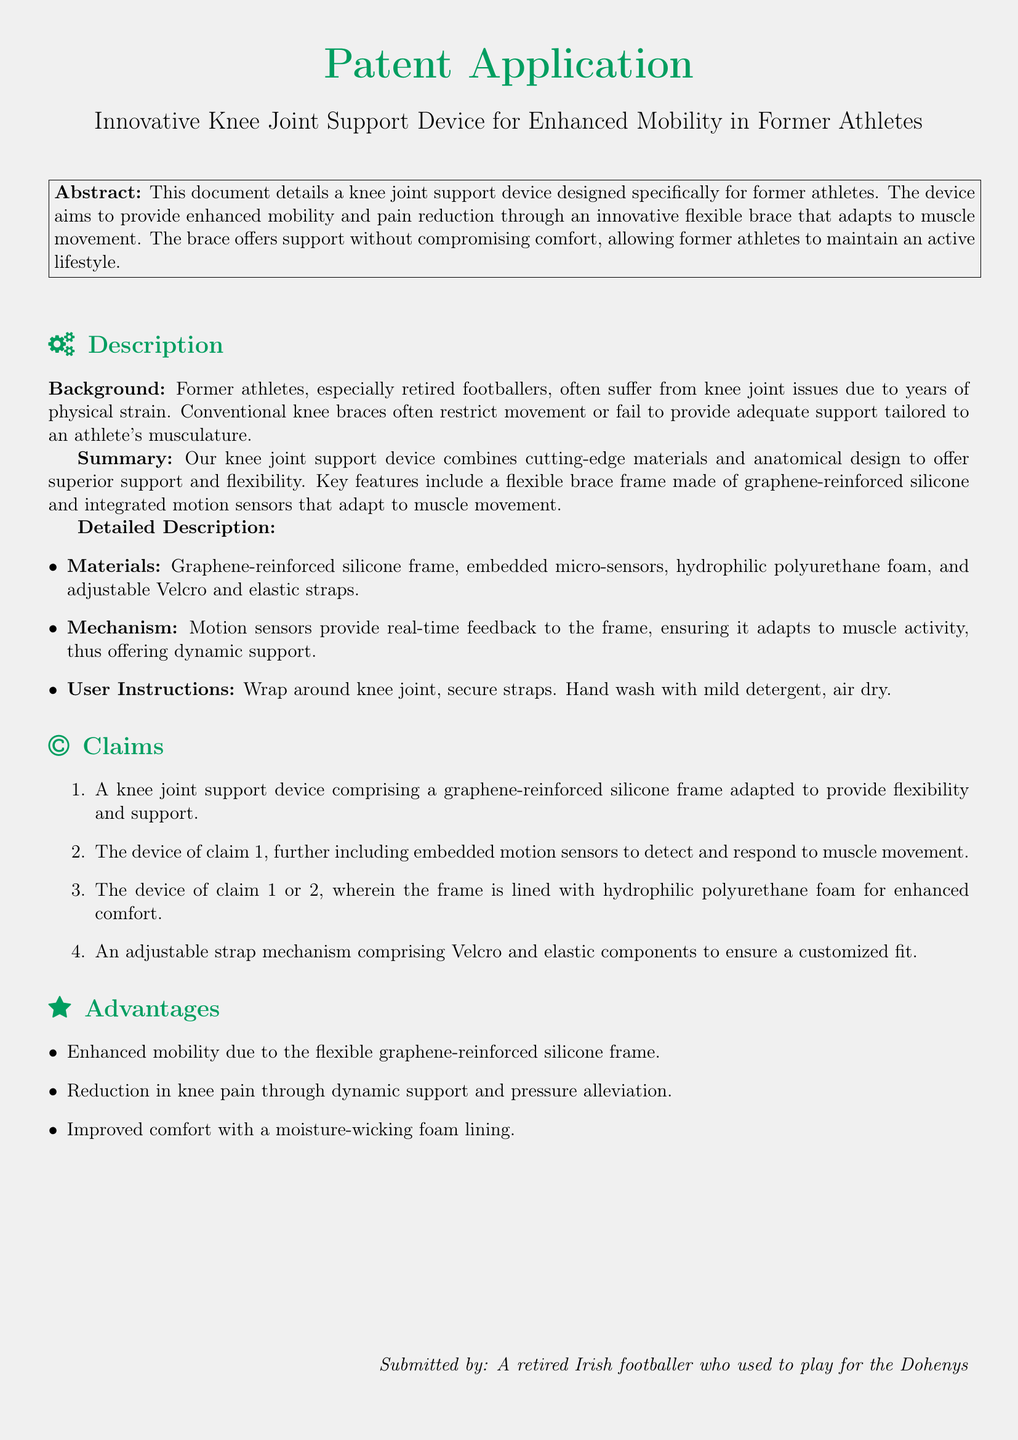What is the main purpose of the device? The main purpose of the device is to provide enhanced mobility and pain reduction for former athletes.
Answer: Enhanced mobility and pain reduction Who is the target user of the knee joint support device? The target user of the device is specifically former athletes.
Answer: Former athletes What material is the frame made of? The frame is made of graphene-reinforced silicone.
Answer: Graphene-reinforced silicone What does the device include to detect muscle movement? The device includes embedded motion sensors.
Answer: Embedded motion sensors How is the comfort of the device improved? The comfort of the device is improved with hydrophilic polyurethane foam lining.
Answer: Hydrophilic polyurethane foam What type of support does the frame provide? The frame provides dynamic support.
Answer: Dynamic support How does the device adapt to muscle activity? The device adapts through motion sensors providing real-time feedback.
Answer: Motion sensors providing real-time feedback What adjustable mechanisms does the device use? The device uses Velcro and elastic straps for adjustment.
Answer: Velcro and elastic straps How should the device be cleaned? The device should be hand washed with mild detergent and air dried.
Answer: Hand wash with mild detergent, air dry 